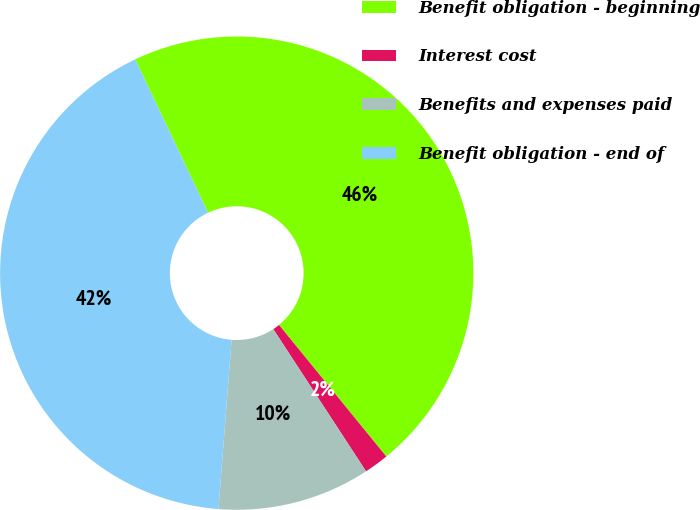<chart> <loc_0><loc_0><loc_500><loc_500><pie_chart><fcel>Benefit obligation - beginning<fcel>Interest cost<fcel>Benefits and expenses paid<fcel>Benefit obligation - end of<nl><fcel>46.17%<fcel>1.69%<fcel>10.43%<fcel>41.72%<nl></chart> 